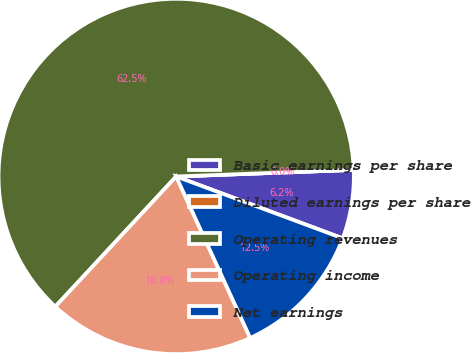Convert chart to OTSL. <chart><loc_0><loc_0><loc_500><loc_500><pie_chart><fcel>Basic earnings per share<fcel>Diluted earnings per share<fcel>Operating revenues<fcel>Operating income<fcel>Net earnings<nl><fcel>6.25%<fcel>0.0%<fcel>62.5%<fcel>18.75%<fcel>12.5%<nl></chart> 